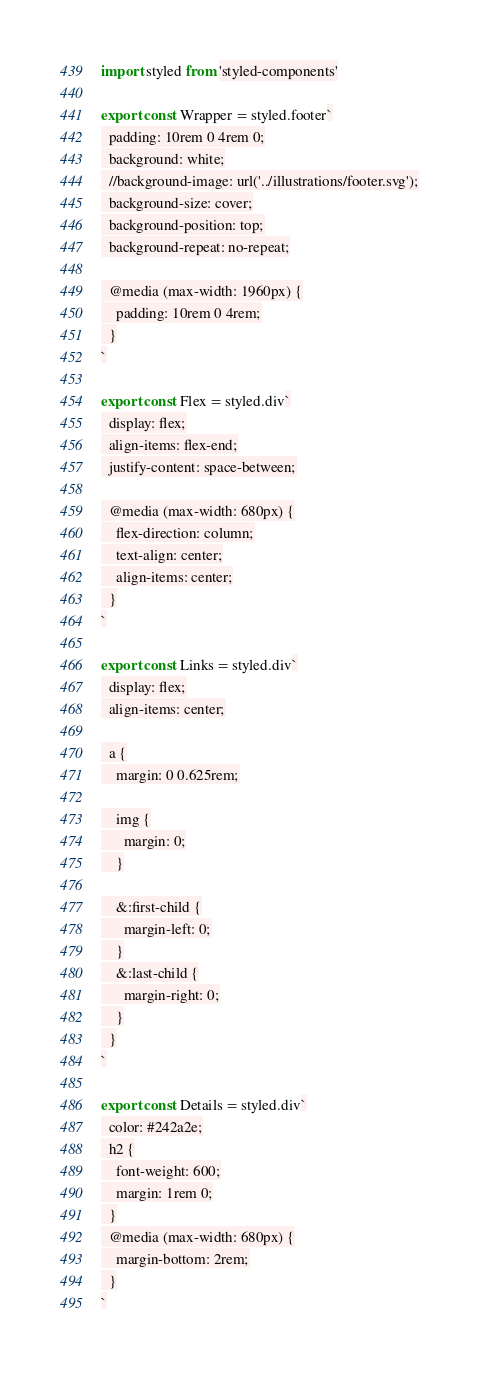<code> <loc_0><loc_0><loc_500><loc_500><_JavaScript_>import styled from 'styled-components'

export const Wrapper = styled.footer`
  padding: 10rem 0 4rem 0;
  background: white;
  //background-image: url('../illustrations/footer.svg');
  background-size: cover;
  background-position: top;
  background-repeat: no-repeat;

  @media (max-width: 1960px) {
    padding: 10rem 0 4rem;
  }
`

export const Flex = styled.div`
  display: flex;
  align-items: flex-end;
  justify-content: space-between;

  @media (max-width: 680px) {
    flex-direction: column;
    text-align: center;
    align-items: center;
  }
`

export const Links = styled.div`
  display: flex;
  align-items: center;

  a {
    margin: 0 0.625rem;

    img {
      margin: 0;
    }

    &:first-child {
      margin-left: 0;
    }
    &:last-child {
      margin-right: 0;
    }
  }
`

export const Details = styled.div`
  color: #242a2e;
  h2 {
    font-weight: 600;
    margin: 1rem 0;
  }
  @media (max-width: 680px) {
    margin-bottom: 2rem;
  }
`
</code> 